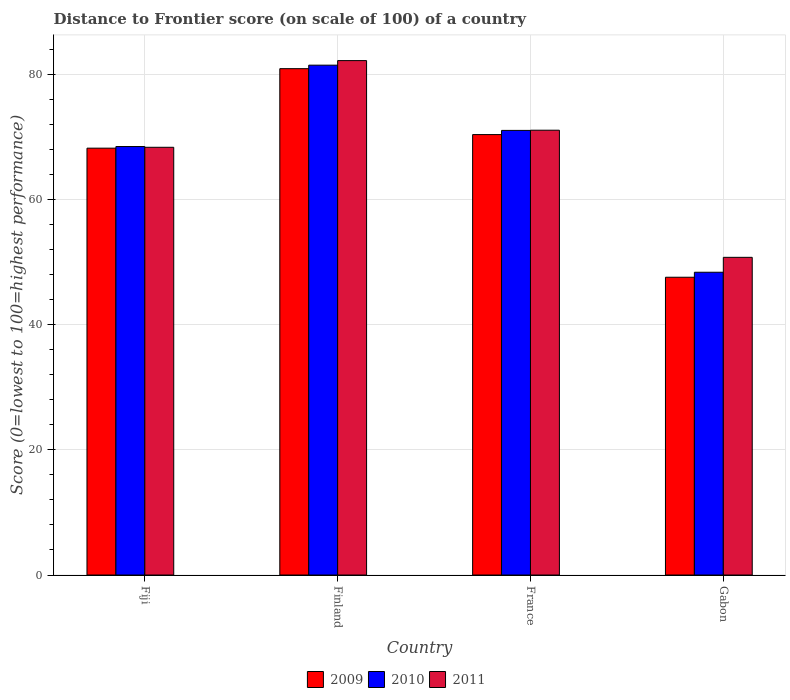How many groups of bars are there?
Offer a very short reply. 4. Are the number of bars per tick equal to the number of legend labels?
Provide a succinct answer. Yes. How many bars are there on the 4th tick from the left?
Offer a terse response. 3. What is the label of the 1st group of bars from the left?
Make the answer very short. Fiji. What is the distance to frontier score of in 2009 in France?
Give a very brief answer. 70.36. Across all countries, what is the maximum distance to frontier score of in 2011?
Keep it short and to the point. 82.18. Across all countries, what is the minimum distance to frontier score of in 2010?
Offer a very short reply. 48.37. In which country was the distance to frontier score of in 2010 maximum?
Offer a very short reply. Finland. In which country was the distance to frontier score of in 2010 minimum?
Your response must be concise. Gabon. What is the total distance to frontier score of in 2010 in the graph?
Give a very brief answer. 269.3. What is the difference between the distance to frontier score of in 2010 in Finland and that in France?
Offer a terse response. 10.42. What is the difference between the distance to frontier score of in 2010 in France and the distance to frontier score of in 2011 in Finland?
Offer a terse response. -11.15. What is the average distance to frontier score of in 2010 per country?
Provide a short and direct response. 67.33. What is the difference between the distance to frontier score of of/in 2009 and distance to frontier score of of/in 2011 in Gabon?
Make the answer very short. -3.18. In how many countries, is the distance to frontier score of in 2011 greater than 52?
Offer a terse response. 3. What is the ratio of the distance to frontier score of in 2009 in Finland to that in France?
Provide a succinct answer. 1.15. Is the difference between the distance to frontier score of in 2009 in Fiji and Gabon greater than the difference between the distance to frontier score of in 2011 in Fiji and Gabon?
Ensure brevity in your answer.  Yes. What is the difference between the highest and the second highest distance to frontier score of in 2010?
Make the answer very short. 13. What is the difference between the highest and the lowest distance to frontier score of in 2011?
Your answer should be very brief. 31.43. In how many countries, is the distance to frontier score of in 2010 greater than the average distance to frontier score of in 2010 taken over all countries?
Offer a very short reply. 3. Is the sum of the distance to frontier score of in 2009 in Fiji and Finland greater than the maximum distance to frontier score of in 2011 across all countries?
Your response must be concise. Yes. What does the 1st bar from the left in Fiji represents?
Ensure brevity in your answer.  2009. What does the 2nd bar from the right in Finland represents?
Ensure brevity in your answer.  2010. Are all the bars in the graph horizontal?
Your answer should be compact. No. What is the difference between two consecutive major ticks on the Y-axis?
Offer a terse response. 20. Does the graph contain any zero values?
Offer a terse response. No. Does the graph contain grids?
Your response must be concise. Yes. How many legend labels are there?
Your answer should be compact. 3. What is the title of the graph?
Provide a short and direct response. Distance to Frontier score (on scale of 100) of a country. What is the label or title of the X-axis?
Offer a very short reply. Country. What is the label or title of the Y-axis?
Keep it short and to the point. Score (0=lowest to 100=highest performance). What is the Score (0=lowest to 100=highest performance) of 2009 in Fiji?
Your answer should be very brief. 68.19. What is the Score (0=lowest to 100=highest performance) of 2010 in Fiji?
Your answer should be compact. 68.45. What is the Score (0=lowest to 100=highest performance) of 2011 in Fiji?
Provide a short and direct response. 68.33. What is the Score (0=lowest to 100=highest performance) of 2009 in Finland?
Keep it short and to the point. 80.89. What is the Score (0=lowest to 100=highest performance) of 2010 in Finland?
Your answer should be compact. 81.45. What is the Score (0=lowest to 100=highest performance) in 2011 in Finland?
Offer a terse response. 82.18. What is the Score (0=lowest to 100=highest performance) of 2009 in France?
Provide a short and direct response. 70.36. What is the Score (0=lowest to 100=highest performance) in 2010 in France?
Your answer should be compact. 71.03. What is the Score (0=lowest to 100=highest performance) of 2011 in France?
Your answer should be compact. 71.06. What is the Score (0=lowest to 100=highest performance) in 2009 in Gabon?
Offer a very short reply. 47.57. What is the Score (0=lowest to 100=highest performance) of 2010 in Gabon?
Your answer should be very brief. 48.37. What is the Score (0=lowest to 100=highest performance) in 2011 in Gabon?
Ensure brevity in your answer.  50.75. Across all countries, what is the maximum Score (0=lowest to 100=highest performance) of 2009?
Your response must be concise. 80.89. Across all countries, what is the maximum Score (0=lowest to 100=highest performance) in 2010?
Give a very brief answer. 81.45. Across all countries, what is the maximum Score (0=lowest to 100=highest performance) in 2011?
Ensure brevity in your answer.  82.18. Across all countries, what is the minimum Score (0=lowest to 100=highest performance) of 2009?
Give a very brief answer. 47.57. Across all countries, what is the minimum Score (0=lowest to 100=highest performance) of 2010?
Your answer should be compact. 48.37. Across all countries, what is the minimum Score (0=lowest to 100=highest performance) of 2011?
Your response must be concise. 50.75. What is the total Score (0=lowest to 100=highest performance) in 2009 in the graph?
Make the answer very short. 267.01. What is the total Score (0=lowest to 100=highest performance) in 2010 in the graph?
Your answer should be compact. 269.3. What is the total Score (0=lowest to 100=highest performance) in 2011 in the graph?
Offer a very short reply. 272.32. What is the difference between the Score (0=lowest to 100=highest performance) in 2009 in Fiji and that in Finland?
Offer a very short reply. -12.7. What is the difference between the Score (0=lowest to 100=highest performance) in 2011 in Fiji and that in Finland?
Give a very brief answer. -13.85. What is the difference between the Score (0=lowest to 100=highest performance) in 2009 in Fiji and that in France?
Give a very brief answer. -2.17. What is the difference between the Score (0=lowest to 100=highest performance) of 2010 in Fiji and that in France?
Your answer should be compact. -2.58. What is the difference between the Score (0=lowest to 100=highest performance) in 2011 in Fiji and that in France?
Provide a short and direct response. -2.73. What is the difference between the Score (0=lowest to 100=highest performance) in 2009 in Fiji and that in Gabon?
Your answer should be very brief. 20.62. What is the difference between the Score (0=lowest to 100=highest performance) of 2010 in Fiji and that in Gabon?
Provide a short and direct response. 20.08. What is the difference between the Score (0=lowest to 100=highest performance) in 2011 in Fiji and that in Gabon?
Offer a very short reply. 17.58. What is the difference between the Score (0=lowest to 100=highest performance) of 2009 in Finland and that in France?
Your response must be concise. 10.53. What is the difference between the Score (0=lowest to 100=highest performance) of 2010 in Finland and that in France?
Your answer should be very brief. 10.42. What is the difference between the Score (0=lowest to 100=highest performance) of 2011 in Finland and that in France?
Your answer should be very brief. 11.12. What is the difference between the Score (0=lowest to 100=highest performance) of 2009 in Finland and that in Gabon?
Provide a succinct answer. 33.32. What is the difference between the Score (0=lowest to 100=highest performance) of 2010 in Finland and that in Gabon?
Ensure brevity in your answer.  33.08. What is the difference between the Score (0=lowest to 100=highest performance) of 2011 in Finland and that in Gabon?
Provide a succinct answer. 31.43. What is the difference between the Score (0=lowest to 100=highest performance) of 2009 in France and that in Gabon?
Give a very brief answer. 22.79. What is the difference between the Score (0=lowest to 100=highest performance) in 2010 in France and that in Gabon?
Your response must be concise. 22.66. What is the difference between the Score (0=lowest to 100=highest performance) of 2011 in France and that in Gabon?
Offer a very short reply. 20.31. What is the difference between the Score (0=lowest to 100=highest performance) of 2009 in Fiji and the Score (0=lowest to 100=highest performance) of 2010 in Finland?
Make the answer very short. -13.26. What is the difference between the Score (0=lowest to 100=highest performance) of 2009 in Fiji and the Score (0=lowest to 100=highest performance) of 2011 in Finland?
Your answer should be compact. -13.99. What is the difference between the Score (0=lowest to 100=highest performance) in 2010 in Fiji and the Score (0=lowest to 100=highest performance) in 2011 in Finland?
Make the answer very short. -13.73. What is the difference between the Score (0=lowest to 100=highest performance) of 2009 in Fiji and the Score (0=lowest to 100=highest performance) of 2010 in France?
Your answer should be compact. -2.84. What is the difference between the Score (0=lowest to 100=highest performance) in 2009 in Fiji and the Score (0=lowest to 100=highest performance) in 2011 in France?
Keep it short and to the point. -2.87. What is the difference between the Score (0=lowest to 100=highest performance) in 2010 in Fiji and the Score (0=lowest to 100=highest performance) in 2011 in France?
Provide a short and direct response. -2.61. What is the difference between the Score (0=lowest to 100=highest performance) of 2009 in Fiji and the Score (0=lowest to 100=highest performance) of 2010 in Gabon?
Provide a succinct answer. 19.82. What is the difference between the Score (0=lowest to 100=highest performance) of 2009 in Fiji and the Score (0=lowest to 100=highest performance) of 2011 in Gabon?
Your response must be concise. 17.44. What is the difference between the Score (0=lowest to 100=highest performance) of 2009 in Finland and the Score (0=lowest to 100=highest performance) of 2010 in France?
Keep it short and to the point. 9.86. What is the difference between the Score (0=lowest to 100=highest performance) of 2009 in Finland and the Score (0=lowest to 100=highest performance) of 2011 in France?
Make the answer very short. 9.83. What is the difference between the Score (0=lowest to 100=highest performance) in 2010 in Finland and the Score (0=lowest to 100=highest performance) in 2011 in France?
Your answer should be very brief. 10.39. What is the difference between the Score (0=lowest to 100=highest performance) of 2009 in Finland and the Score (0=lowest to 100=highest performance) of 2010 in Gabon?
Ensure brevity in your answer.  32.52. What is the difference between the Score (0=lowest to 100=highest performance) of 2009 in Finland and the Score (0=lowest to 100=highest performance) of 2011 in Gabon?
Provide a short and direct response. 30.14. What is the difference between the Score (0=lowest to 100=highest performance) in 2010 in Finland and the Score (0=lowest to 100=highest performance) in 2011 in Gabon?
Your response must be concise. 30.7. What is the difference between the Score (0=lowest to 100=highest performance) in 2009 in France and the Score (0=lowest to 100=highest performance) in 2010 in Gabon?
Your answer should be compact. 21.99. What is the difference between the Score (0=lowest to 100=highest performance) of 2009 in France and the Score (0=lowest to 100=highest performance) of 2011 in Gabon?
Your response must be concise. 19.61. What is the difference between the Score (0=lowest to 100=highest performance) of 2010 in France and the Score (0=lowest to 100=highest performance) of 2011 in Gabon?
Offer a very short reply. 20.28. What is the average Score (0=lowest to 100=highest performance) in 2009 per country?
Provide a succinct answer. 66.75. What is the average Score (0=lowest to 100=highest performance) of 2010 per country?
Provide a short and direct response. 67.33. What is the average Score (0=lowest to 100=highest performance) in 2011 per country?
Keep it short and to the point. 68.08. What is the difference between the Score (0=lowest to 100=highest performance) in 2009 and Score (0=lowest to 100=highest performance) in 2010 in Fiji?
Your response must be concise. -0.26. What is the difference between the Score (0=lowest to 100=highest performance) in 2009 and Score (0=lowest to 100=highest performance) in 2011 in Fiji?
Offer a terse response. -0.14. What is the difference between the Score (0=lowest to 100=highest performance) of 2010 and Score (0=lowest to 100=highest performance) of 2011 in Fiji?
Offer a terse response. 0.12. What is the difference between the Score (0=lowest to 100=highest performance) of 2009 and Score (0=lowest to 100=highest performance) of 2010 in Finland?
Your answer should be compact. -0.56. What is the difference between the Score (0=lowest to 100=highest performance) in 2009 and Score (0=lowest to 100=highest performance) in 2011 in Finland?
Your answer should be compact. -1.29. What is the difference between the Score (0=lowest to 100=highest performance) in 2010 and Score (0=lowest to 100=highest performance) in 2011 in Finland?
Your answer should be compact. -0.73. What is the difference between the Score (0=lowest to 100=highest performance) in 2009 and Score (0=lowest to 100=highest performance) in 2010 in France?
Make the answer very short. -0.67. What is the difference between the Score (0=lowest to 100=highest performance) in 2009 and Score (0=lowest to 100=highest performance) in 2011 in France?
Make the answer very short. -0.7. What is the difference between the Score (0=lowest to 100=highest performance) of 2010 and Score (0=lowest to 100=highest performance) of 2011 in France?
Ensure brevity in your answer.  -0.03. What is the difference between the Score (0=lowest to 100=highest performance) of 2009 and Score (0=lowest to 100=highest performance) of 2011 in Gabon?
Keep it short and to the point. -3.18. What is the difference between the Score (0=lowest to 100=highest performance) of 2010 and Score (0=lowest to 100=highest performance) of 2011 in Gabon?
Provide a short and direct response. -2.38. What is the ratio of the Score (0=lowest to 100=highest performance) in 2009 in Fiji to that in Finland?
Offer a very short reply. 0.84. What is the ratio of the Score (0=lowest to 100=highest performance) in 2010 in Fiji to that in Finland?
Your answer should be very brief. 0.84. What is the ratio of the Score (0=lowest to 100=highest performance) of 2011 in Fiji to that in Finland?
Make the answer very short. 0.83. What is the ratio of the Score (0=lowest to 100=highest performance) of 2009 in Fiji to that in France?
Your response must be concise. 0.97. What is the ratio of the Score (0=lowest to 100=highest performance) in 2010 in Fiji to that in France?
Make the answer very short. 0.96. What is the ratio of the Score (0=lowest to 100=highest performance) in 2011 in Fiji to that in France?
Keep it short and to the point. 0.96. What is the ratio of the Score (0=lowest to 100=highest performance) in 2009 in Fiji to that in Gabon?
Make the answer very short. 1.43. What is the ratio of the Score (0=lowest to 100=highest performance) of 2010 in Fiji to that in Gabon?
Provide a succinct answer. 1.42. What is the ratio of the Score (0=lowest to 100=highest performance) of 2011 in Fiji to that in Gabon?
Give a very brief answer. 1.35. What is the ratio of the Score (0=lowest to 100=highest performance) of 2009 in Finland to that in France?
Offer a terse response. 1.15. What is the ratio of the Score (0=lowest to 100=highest performance) of 2010 in Finland to that in France?
Provide a short and direct response. 1.15. What is the ratio of the Score (0=lowest to 100=highest performance) in 2011 in Finland to that in France?
Offer a terse response. 1.16. What is the ratio of the Score (0=lowest to 100=highest performance) of 2009 in Finland to that in Gabon?
Your response must be concise. 1.7. What is the ratio of the Score (0=lowest to 100=highest performance) of 2010 in Finland to that in Gabon?
Provide a succinct answer. 1.68. What is the ratio of the Score (0=lowest to 100=highest performance) of 2011 in Finland to that in Gabon?
Your response must be concise. 1.62. What is the ratio of the Score (0=lowest to 100=highest performance) in 2009 in France to that in Gabon?
Offer a very short reply. 1.48. What is the ratio of the Score (0=lowest to 100=highest performance) in 2010 in France to that in Gabon?
Offer a terse response. 1.47. What is the ratio of the Score (0=lowest to 100=highest performance) of 2011 in France to that in Gabon?
Your answer should be very brief. 1.4. What is the difference between the highest and the second highest Score (0=lowest to 100=highest performance) in 2009?
Give a very brief answer. 10.53. What is the difference between the highest and the second highest Score (0=lowest to 100=highest performance) of 2010?
Provide a short and direct response. 10.42. What is the difference between the highest and the second highest Score (0=lowest to 100=highest performance) of 2011?
Offer a very short reply. 11.12. What is the difference between the highest and the lowest Score (0=lowest to 100=highest performance) of 2009?
Your answer should be compact. 33.32. What is the difference between the highest and the lowest Score (0=lowest to 100=highest performance) of 2010?
Give a very brief answer. 33.08. What is the difference between the highest and the lowest Score (0=lowest to 100=highest performance) in 2011?
Provide a short and direct response. 31.43. 